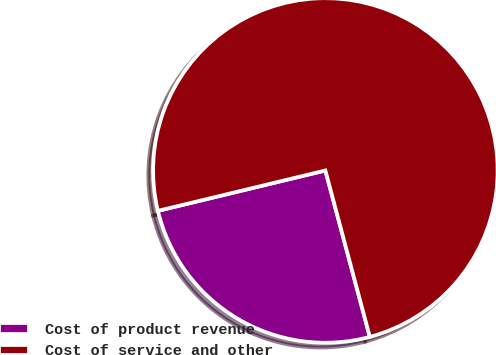Convert chart. <chart><loc_0><loc_0><loc_500><loc_500><pie_chart><fcel>Cost of product revenue<fcel>Cost of service and other<nl><fcel>25.39%<fcel>74.61%<nl></chart> 